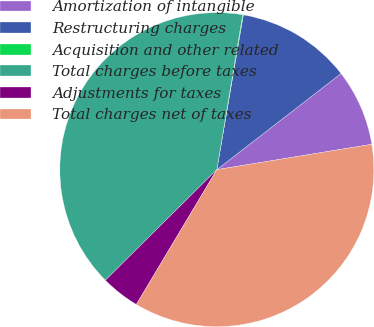Convert chart. <chart><loc_0><loc_0><loc_500><loc_500><pie_chart><fcel>Amortization of intangible<fcel>Restructuring charges<fcel>Acquisition and other related<fcel>Total charges before taxes<fcel>Adjustments for taxes<fcel>Total charges net of taxes<nl><fcel>7.9%<fcel>11.82%<fcel>0.07%<fcel>40.07%<fcel>3.99%<fcel>36.15%<nl></chart> 